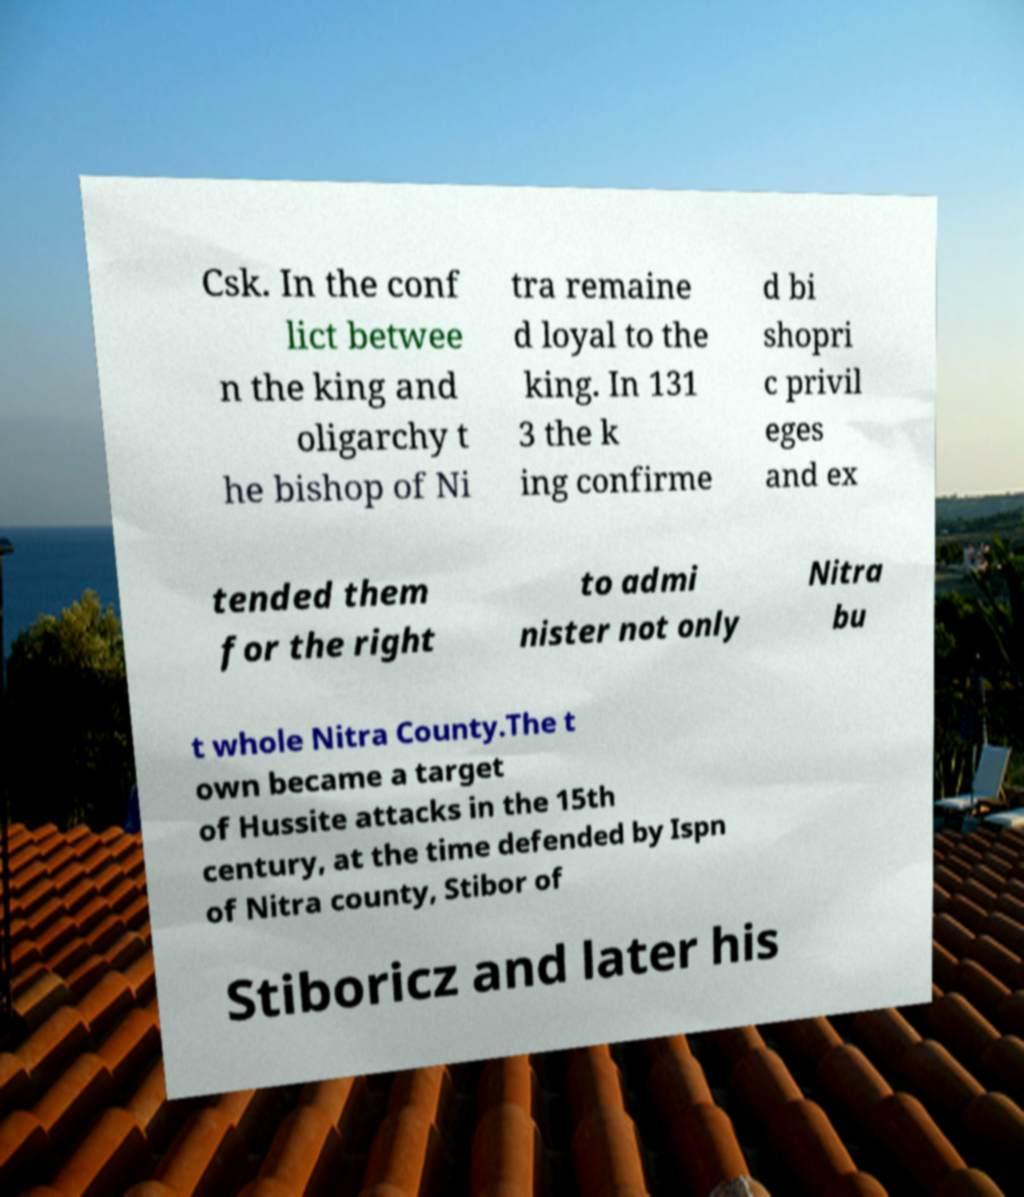Can you accurately transcribe the text from the provided image for me? Csk. In the conf lict betwee n the king and oligarchy t he bishop of Ni tra remaine d loyal to the king. In 131 3 the k ing confirme d bi shopri c privil eges and ex tended them for the right to admi nister not only Nitra bu t whole Nitra County.The t own became a target of Hussite attacks in the 15th century, at the time defended by Ispn of Nitra county, Stibor of Stiboricz and later his 